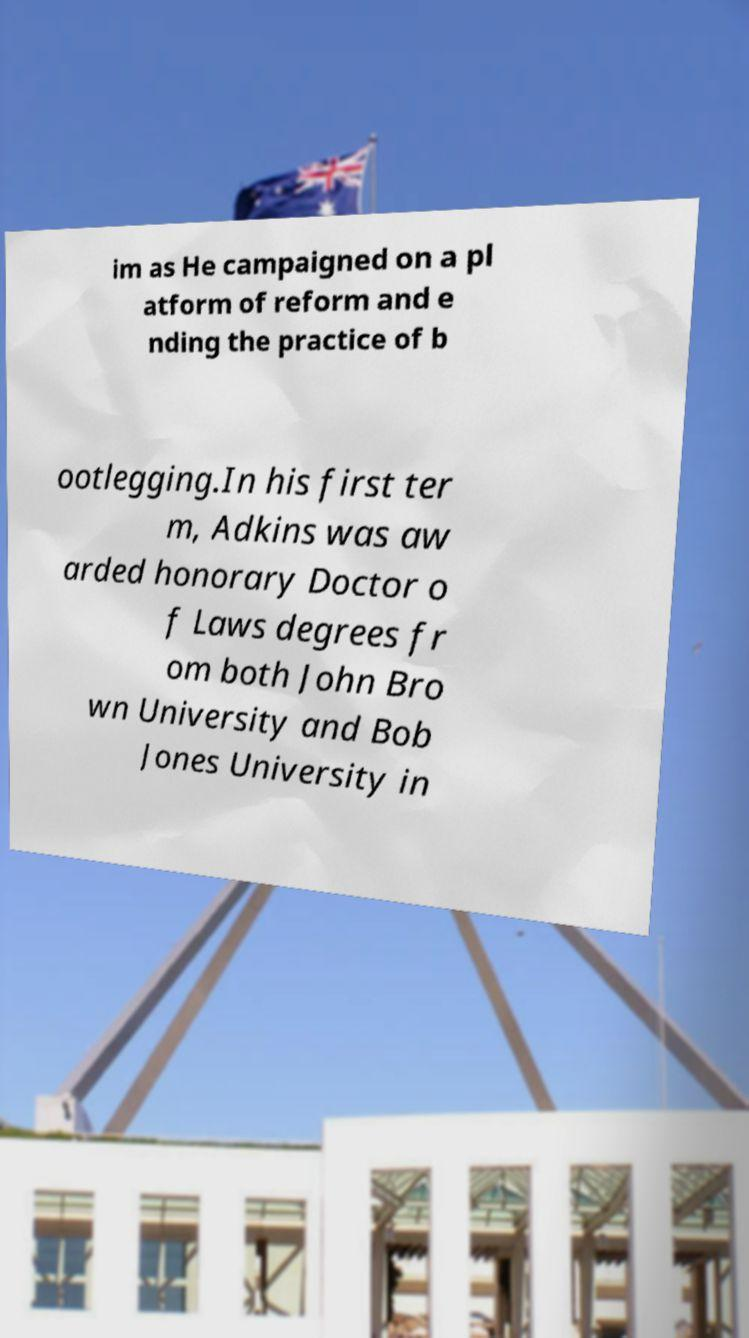I need the written content from this picture converted into text. Can you do that? im as He campaigned on a pl atform of reform and e nding the practice of b ootlegging.In his first ter m, Adkins was aw arded honorary Doctor o f Laws degrees fr om both John Bro wn University and Bob Jones University in 